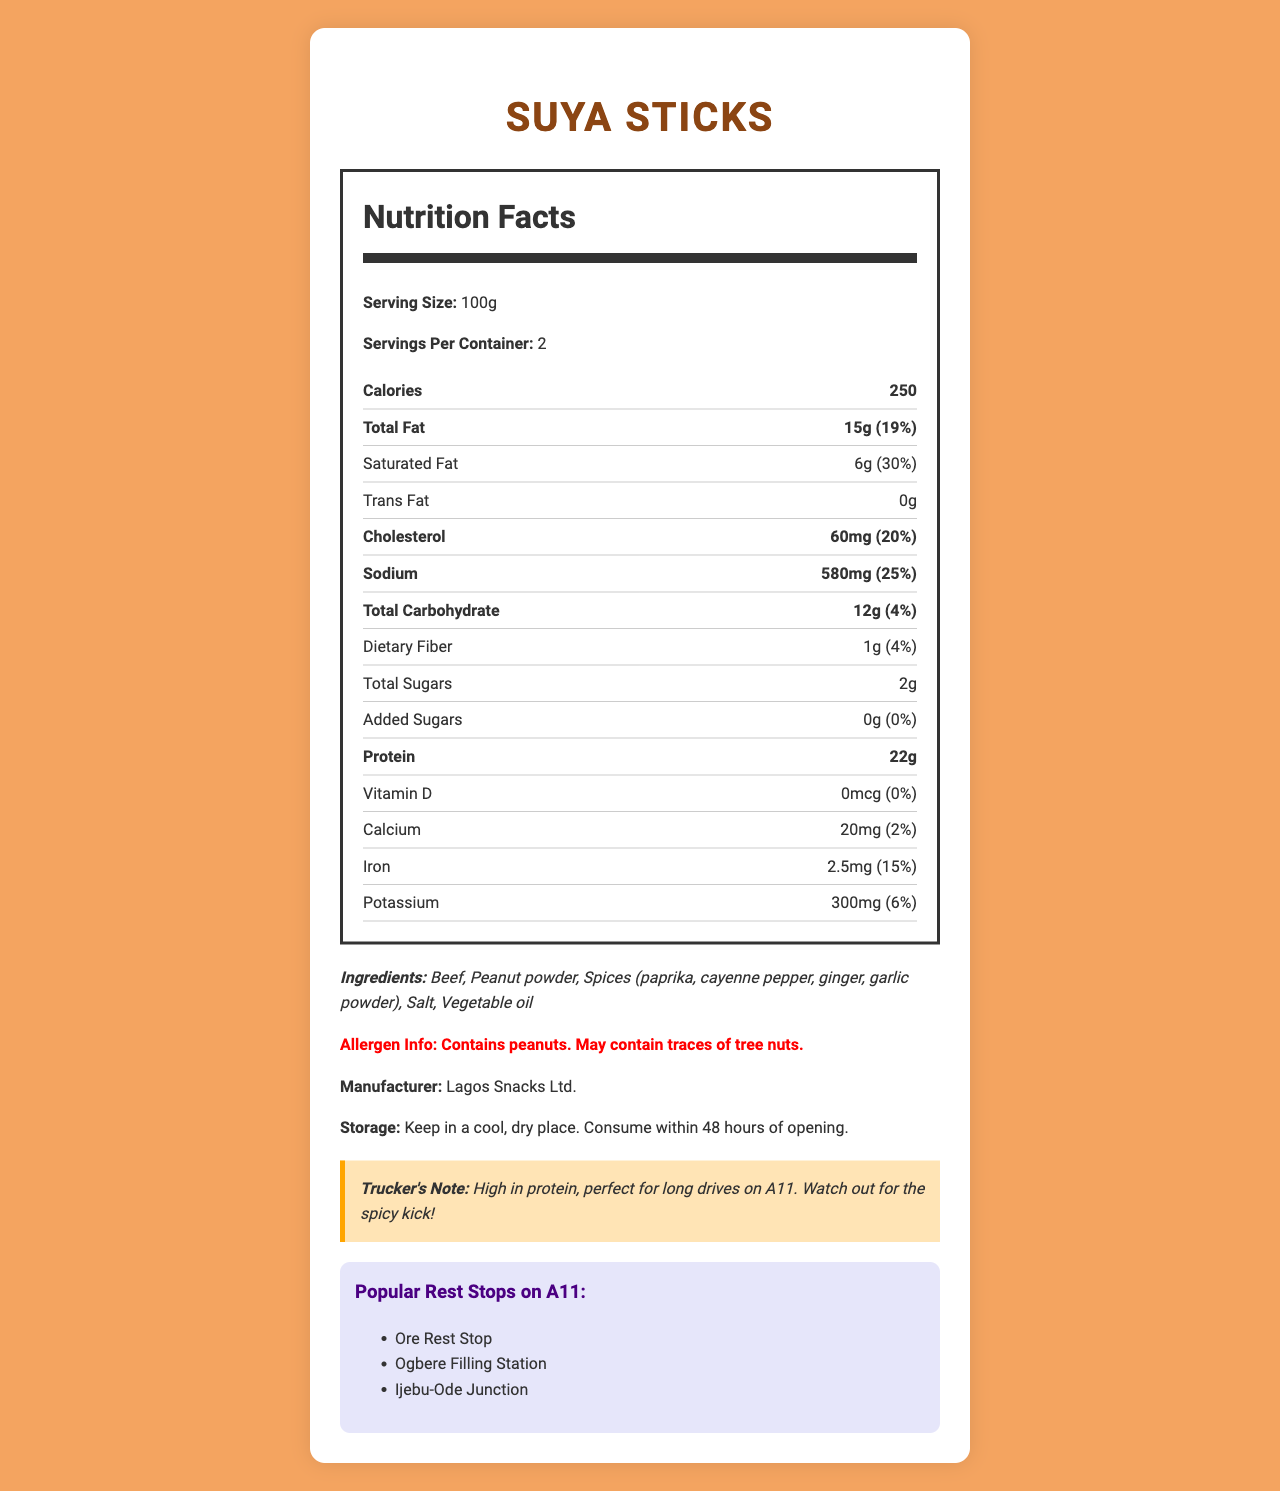what is the serving size of Suya Sticks? The serving size is explicitly mentioned in the Nutrition Facts section of the document.
Answer: 100g how many calories are in one serving of Suya Sticks? The number of calories per serving is provided in the Nutrition Facts section.
Answer: 250 how much protein is in one serving of Suya Sticks? The amount of protein per serving is indicated in the Nutrition Facts section.
Answer: 22g what are the ingredients in Suya Sticks? The ingredients are listed under the "Ingredients" section of the document.
Answer: Beef, Peanut powder, Spices (paprika, cayenne pepper, ginger, garlic powder), Salt, Vegetable oil how much sodium is in one serving of Suya Sticks? The amount of sodium per serving is specified in the Nutrition Facts section.
Answer: 580mg which of the following nutrients has the highest daily value percentage in Suya Sticks? A. Vitamin D B. Iron C. Saturated Fat D. Calcium The saturated fat has a daily value of 30%, which is higher than Vitamin D (0%), Iron (15%), and Calcium (2%).
Answer: C. Saturated Fat which manufacturer produces Suya Sticks? A. Lagos Snacks Ltd. B. Abuja Delicacies Inc. C. Kano Treats D. Port Harcourt Foods The manufacturer is listed as Lagos Snacks Ltd. in the document.
Answer: A. Lagos Snacks Ltd. is there any trans fat in Suya Sticks? The document shows that the amount of trans fat is 0g.
Answer: No can I consume Suya Sticks if I have a peanut allergy? The allergen info states that the product contains peanuts, making it unsafe for those with a peanut allergy.
Answer: No where should I store Suya Sticks after opening? The storage instructions in the document recommend keeping the product in a cool, dry place and consuming it within 48 hours.
Answer: In a cool, dry place describe the main idea of the document. The document serves to inform potential consumers, especially truck drivers, about the nutritional content, ingredients, allergen warnings, and storage requirements of the Suya Sticks. It also highlights where the snack can be purchased along the A11 highway and provides a specific note about its suitability as a high-protein snack ideal for long drives.
Answer: The document provides detailed nutrition facts and ingredients information about Suya Sticks, a popular Nigerian snack sold at rest stops along the A11 highway. It includes serving size, calorie content, nutrient breakdown, allergen information, manufacturer details, and storage instructions. Additionally, it highlights popular rest stops where the snack is available and includes a special note for truck drivers. what is the amount of potassium in Suya Sticks? The amount of potassium in one serving is listed in the Nutrition Facts section.
Answer: 300mg is the document professional-looking and clear to understand? The document is well-organized with clear headings and sections, making it easy for readers to find and understand the information.
Answer: Yes how much saturated fat is in one entire container of Suya Sticks? Each serving contains 6g of saturated fat, and there are 2 servings per container, resulting in a total of 12g of saturated fat per container.
Answer: 12g what is the exact amount of calcium in Suya Sticks? The exact amount of calcium per serving is provided in the Nutrition Facts section.
Answer: 20mg what is the trucker's note about Suya Sticks? This specific note for truck drivers provides insight into the suitability of the snack for long drives and warns about its spiciness.
Answer: High in protein, perfect for long drives on A11. Watch out for the spicy kick! what is the main ingredient in Suya Sticks? The first ingredient listed is Beef, indicating it is the main ingredient.
Answer: Beef how much total carbohydrate is in one serving of Suya Sticks? The total carbohydrate content per serving is listed in the Nutrition Facts section.
Answer: 12g what percentage of the daily value of iron does Suya Sticks provide? The daily value percentage of iron provided by Suya Sticks is listed as 15%.
Answer: 15% why is Suya Sticks considered perfect for long drives on A11? The trucker's note mentions that it is high in protein, which is ideal for sustained energy during long drives.
Answer: High in protein, perfect for long drives on A11. Watch out for the spicy kick! 